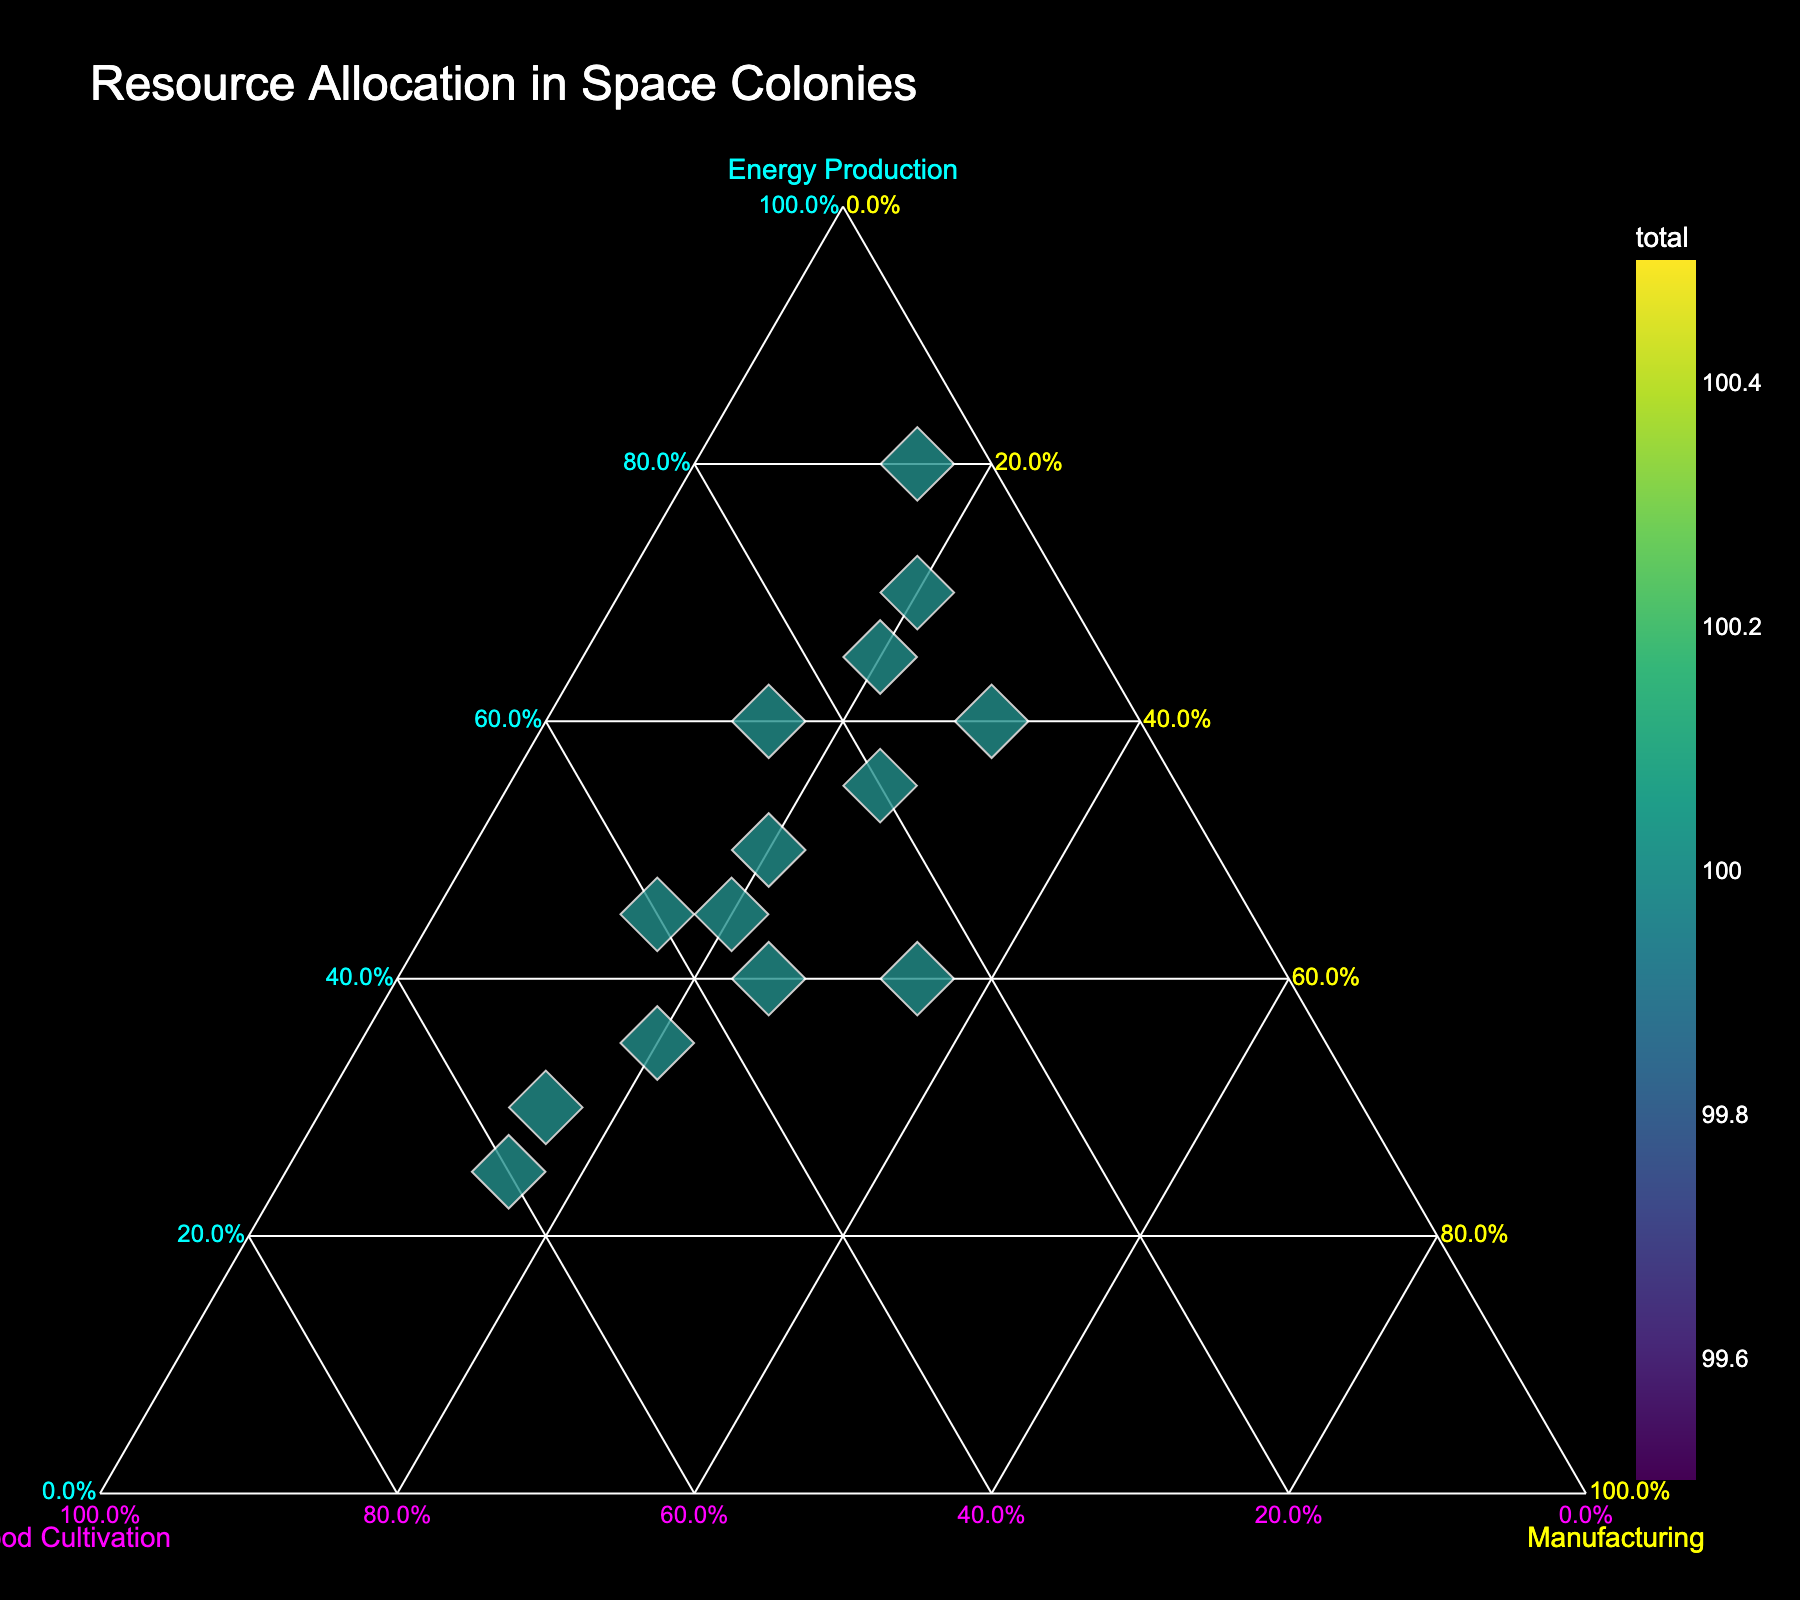What is the title of the figure? The title is displayed prominently at the top of the plot. It serves as an introductory description.
Answer: Resource Allocation in Space Colonies How many data points are represented in the figure? Each data point corresponds to a space colony listed in the dataset. Count the total colonies.
Answer: 14 Which colony has the highest allocation for Energy Production? Look for the point closest to the "Energy Production" axis and cross-reference with the colony name in the hover text.
Answer: Mercury Solar Array Which colony has the largest total resource allocation? Identify the colony with the largest marker size, as size represents total resource allocation in the plot.
Answer: Mercury Solar Array What's the median value of total resource allocation? List all total values, sort them, and find the middle value. If there is an even number of values, calculate the average of the two middle values.
Answer: 40 How much energy production is allocated for the Io Geothermal Complex in percentage form? Hover over the point labeled 'Io Geothermal Complex' and check the Energy percentage shown.
Answer: 70% Which colony balances its resource allocation most evenly across the three categories? Look for the point closest to the center of the ternary plot, where the three percentages would be most equal. Cross-reference with the colony name in the hover text.
Answer: Callisto Industrial Zone By what percentage does Venus Cloud City allocate more resources to Food Cultivation compared to Manufacturing Capabilities? Find the percentages for Food Cultivation and Manufacturing Capabilities for Venus Cloud City, then subtract to find the difference.
Answer: 15% Which two colonies have the closest total resource allocation values? Compare the sizes of the markers and identify the colonies with the most similar total sizes from the hover text.
Answer: Asteroid Belt Hub and Callisto Industrial Zone Among Ganymede Research Center and Enceladus Aquaculture, which colony allocates more resources to Food Cultivation? Find both colonies on the plot and compare their Food Cultivation percentages shown in the hover text.
Answer: Enceladus Aquaculture 